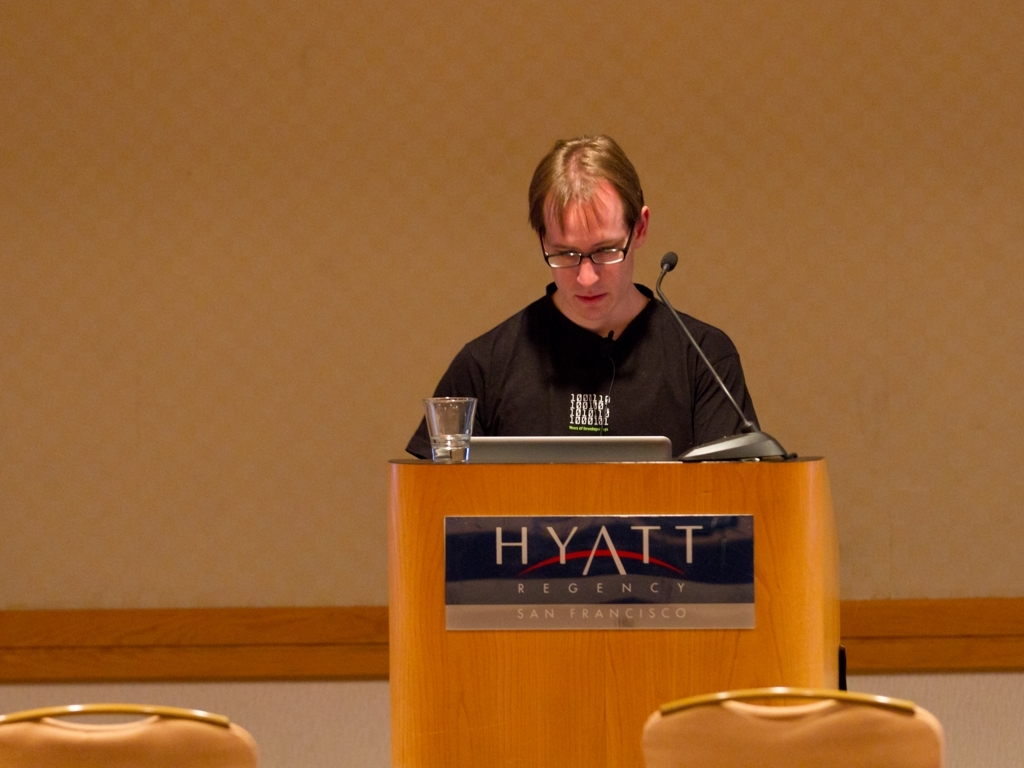Are there any quality issues with this image? Yes, the image exhibits a slight blur affecting overall sharpness, and there's underexposure making details less visible, especially in the background. Furthermore, the framing could be improved to better focus on the subject, and the lighting appears uneven. 